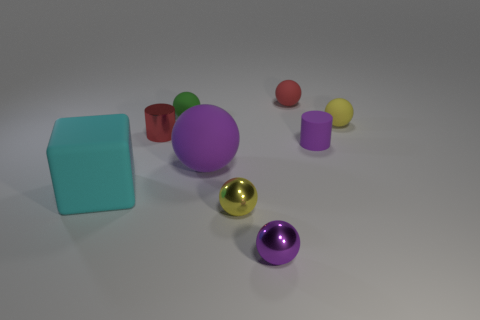Which objects in the image appear to have a shiny surface? The objects with a shiny surface are the golden sphere and the small purple cylinder in front of it. Their glossy textures reflect the light, giving them a shiny appearance. 